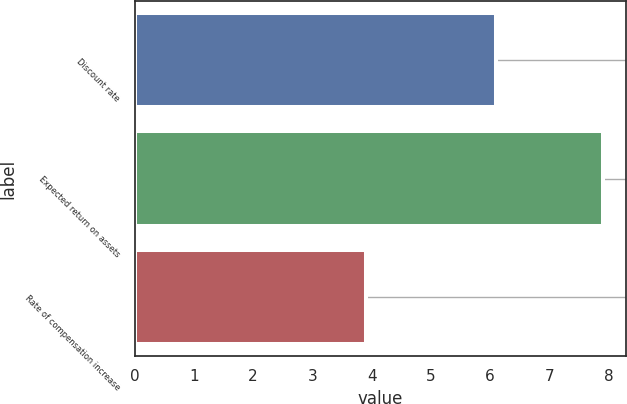Convert chart. <chart><loc_0><loc_0><loc_500><loc_500><bar_chart><fcel>Discount rate<fcel>Expected return on assets<fcel>Rate of compensation increase<nl><fcel>6.1<fcel>7.9<fcel>3.9<nl></chart> 